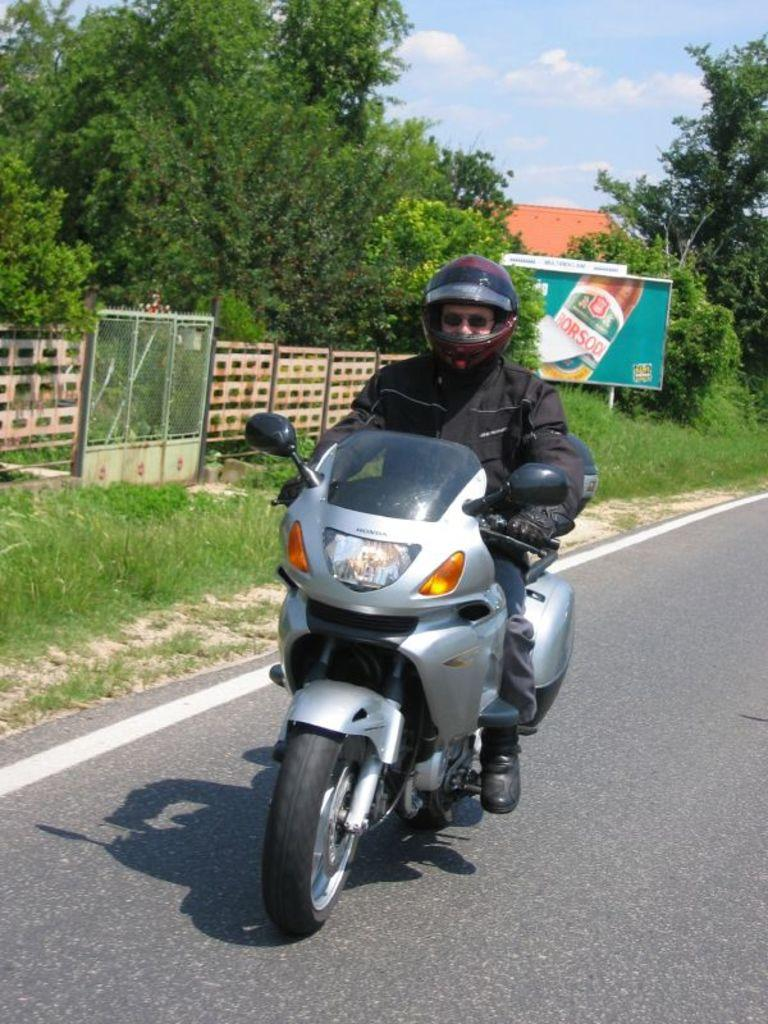What is the man in the image doing? The man is riding a motorcycle in the image. What safety precaution is the man taking while riding the motorcycle? The man is wearing a helmet. Where is the motorcycle located? The motorcycle is on the road. What can be seen in the background of the image? There is a hoarding, trees, and a house in the background of the image. What type of plants can be seen growing in the man's veins in the image? There are no plants visible in the man's veins in the image, as veins are not visible in the image and plants are not associated with veins. 